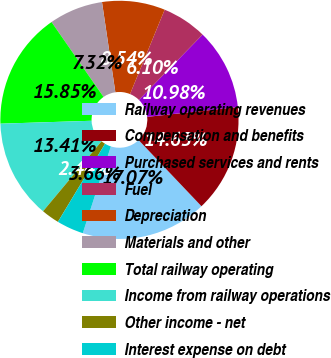<chart> <loc_0><loc_0><loc_500><loc_500><pie_chart><fcel>Railway operating revenues<fcel>Compensation and benefits<fcel>Purchased services and rents<fcel>Fuel<fcel>Depreciation<fcel>Materials and other<fcel>Total railway operating<fcel>Income from railway operations<fcel>Other income - net<fcel>Interest expense on debt<nl><fcel>17.07%<fcel>14.63%<fcel>10.98%<fcel>6.1%<fcel>8.54%<fcel>7.32%<fcel>15.85%<fcel>13.41%<fcel>2.44%<fcel>3.66%<nl></chart> 